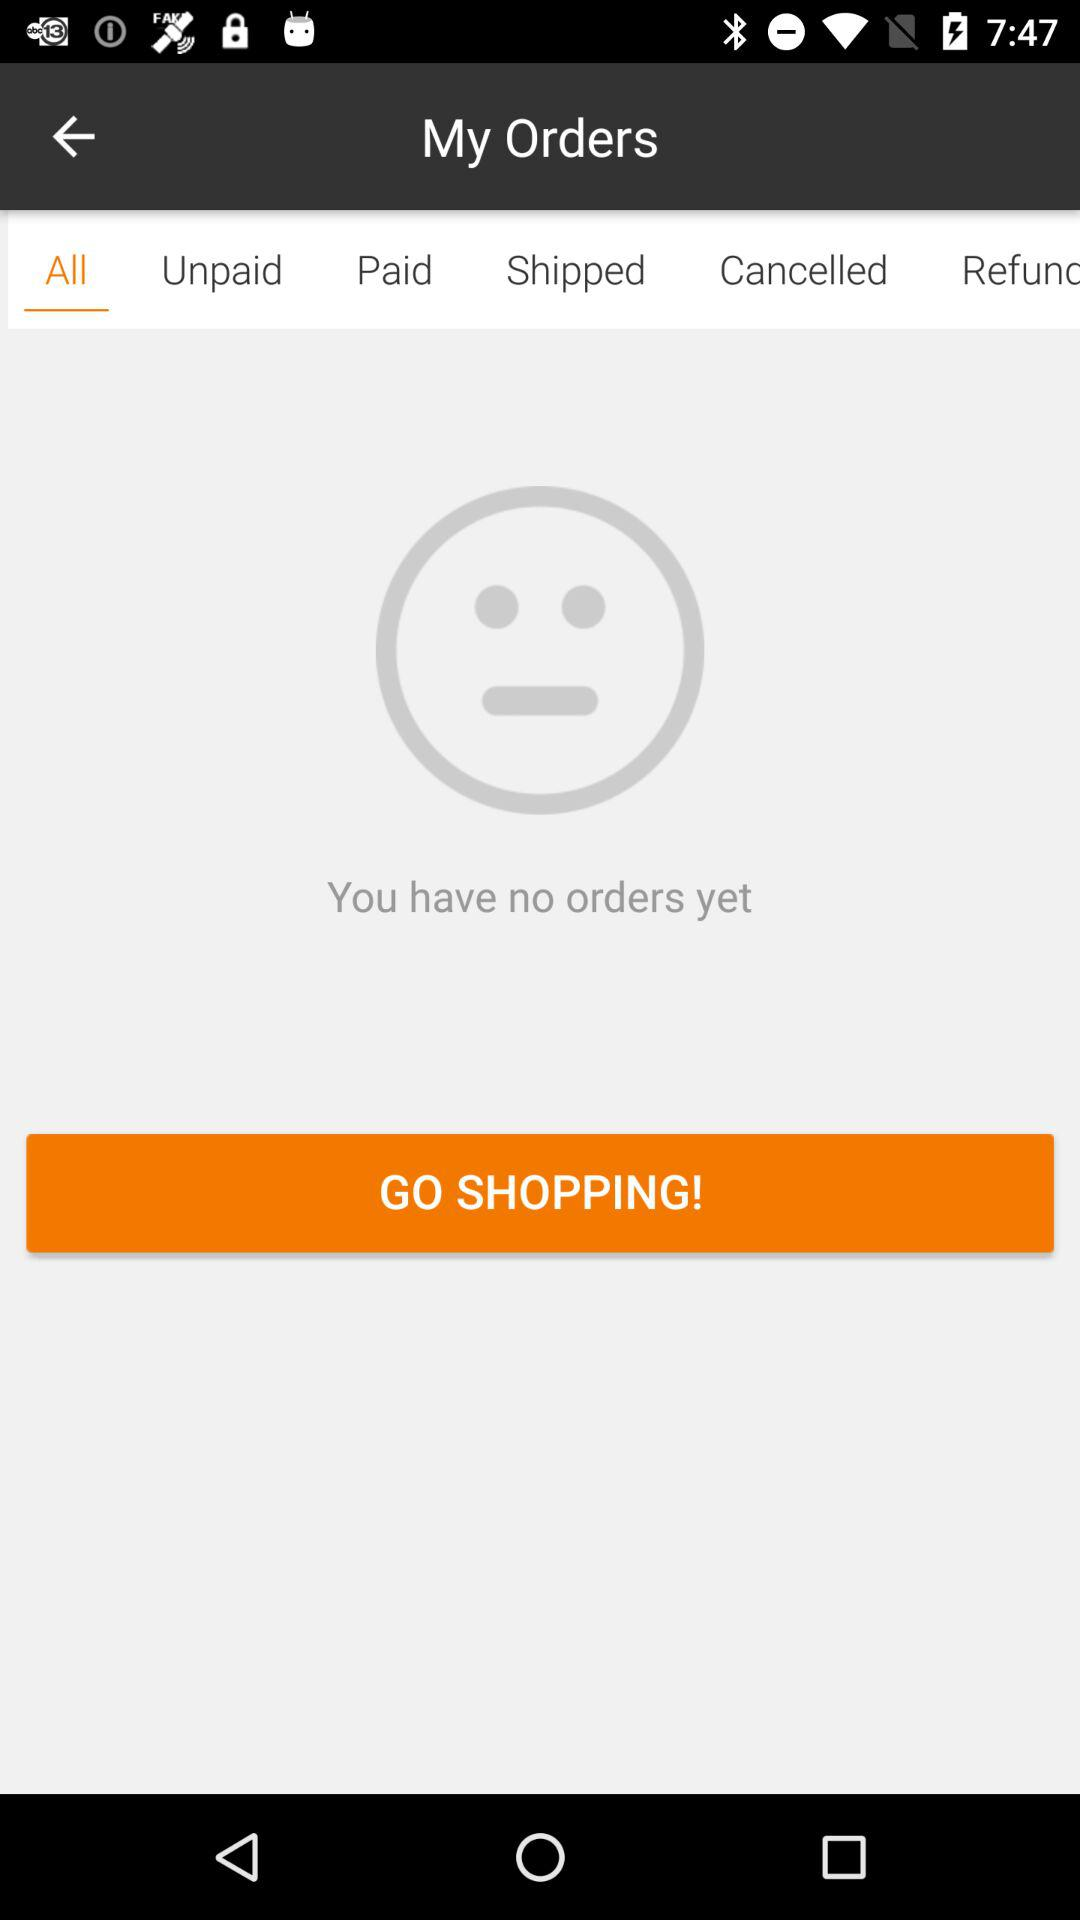How many orders do I have?
Answer the question using a single word or phrase. 0 